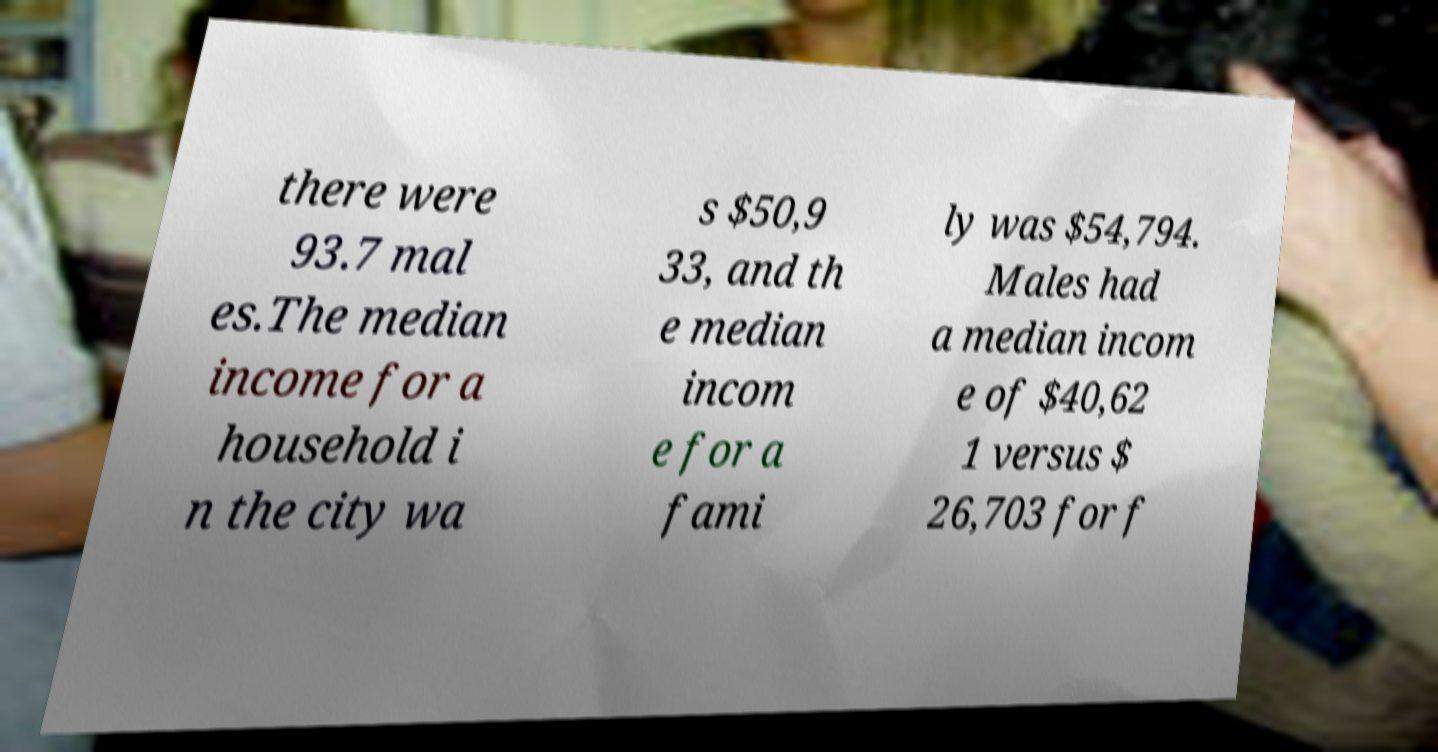For documentation purposes, I need the text within this image transcribed. Could you provide that? there were 93.7 mal es.The median income for a household i n the city wa s $50,9 33, and th e median incom e for a fami ly was $54,794. Males had a median incom e of $40,62 1 versus $ 26,703 for f 